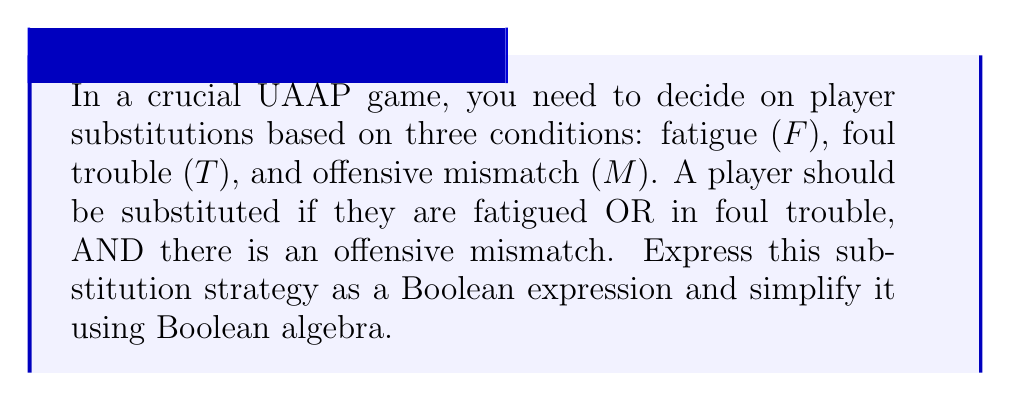What is the answer to this math problem? Let's approach this step-by-step:

1) First, we need to translate the given conditions into a Boolean expression:
   - Player is fatigued OR in foul trouble: $(F + T)$
   - AND there is an offensive mismatch: $M$

   So, the initial Boolean expression is: $(F + T) \cdot M$

2) This expression is already in its simplest form, but let's verify using Boolean algebra laws:

   $$(F + T) \cdot M$$

3) We can use the distributive law to expand this:

   $$F \cdot M + T \cdot M$$

4) This expanded form is equivalent to our original expression. Since there are no common terms to factor out or simplify further, our original expression $(F + T) \cdot M$ is indeed the simplest form.

5) In Boolean algebra terms, this expression represents:
   - Substitute if (Fatigue OR Foul trouble) AND Offensive mismatch

This Boolean expression efficiently represents the coach's substitution strategy, considering all three factors simultaneously.
Answer: $(F + T) \cdot M$ 